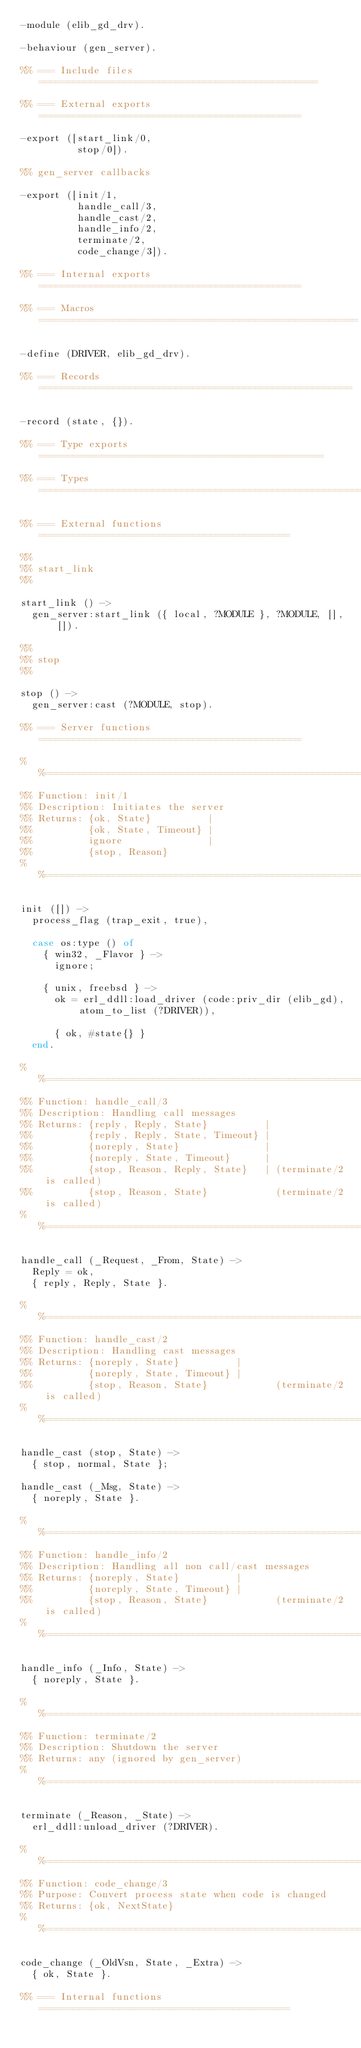Convert code to text. <code><loc_0><loc_0><loc_500><loc_500><_Erlang_>-module (elib_gd_drv).

-behaviour (gen_server).

%% === Include files =================================================

%% === External exports ==============================================

-export ([start_link/0,
          stop/0]).

%% gen_server callbacks

-export ([init/1,
          handle_call/3,
          handle_cast/2,
          handle_info/2,
          terminate/2,
          code_change/3]).

%% === Internal exports ==============================================

%% === Macros ========================================================

-define (DRIVER, elib_gd_drv).

%% === Records =======================================================

-record (state, {}).

%% === Type exports ==================================================

%% === Types =========================================================

%% === External functions ============================================

%%
%% start_link
%%

start_link () ->
  gen_server:start_link ({ local, ?MODULE }, ?MODULE, [], []).

%%
%% stop
%%

stop () ->
  gen_server:cast (?MODULE, stop).

%% === Server functions ==============================================

%%====================================================================
%% Function: init/1
%% Description: Initiates the server
%% Returns: {ok, State}          |
%%          {ok, State, Timeout} |
%%          ignore               |
%%          {stop, Reason}
%%====================================================================

init ([]) ->
  process_flag (trap_exit, true),

  case os:type () of
    { win32, _Flavor } ->
      ignore;

    { unix, freebsd } ->
      ok = erl_ddll:load_driver (code:priv_dir (elib_gd), atom_to_list (?DRIVER)),

      { ok, #state{} }
  end.

%%====================================================================
%% Function: handle_call/3
%% Description: Handling call messages
%% Returns: {reply, Reply, State}          |
%%          {reply, Reply, State, Timeout} |
%%          {noreply, State}               |
%%          {noreply, State, Timeout}      |
%%          {stop, Reason, Reply, State}   | (terminate/2 is called)
%%          {stop, Reason, State}            (terminate/2 is called)
%%====================================================================

handle_call (_Request, _From, State) ->
  Reply = ok,
  { reply, Reply, State }.

%%====================================================================
%% Function: handle_cast/2
%% Description: Handling cast messages
%% Returns: {noreply, State}          |
%%          {noreply, State, Timeout} |
%%          {stop, Reason, State}            (terminate/2 is called)
%%====================================================================

handle_cast (stop, State) ->
  { stop, normal, State };

handle_cast (_Msg, State) ->
  { noreply, State }.

%%====================================================================
%% Function: handle_info/2
%% Description: Handling all non call/cast messages
%% Returns: {noreply, State}          |
%%          {noreply, State, Timeout} |
%%          {stop, Reason, State}            (terminate/2 is called)
%%====================================================================

handle_info (_Info, State) ->
  { noreply, State }.

%%====================================================================
%% Function: terminate/2
%% Description: Shutdown the server
%% Returns: any (ignored by gen_server)
%%====================================================================

terminate (_Reason, _State) ->
  erl_ddll:unload_driver (?DRIVER).

%%====================================================================
%% Function: code_change/3
%% Purpose: Convert process state when code is changed
%% Returns: {ok, NextState}
%%====================================================================

code_change (_OldVsn, State, _Extra) ->
  { ok, State }.

%% === Internal functions ============================================
</code> 